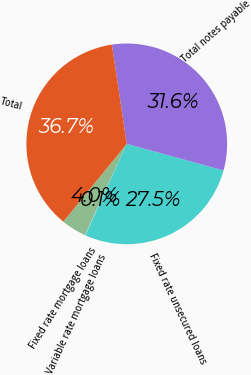<chart> <loc_0><loc_0><loc_500><loc_500><pie_chart><fcel>Fixed rate mortgage loans<fcel>Variable rate mortgage loans<fcel>Fixed rate unsecured loans<fcel>Total notes payable<fcel>Total<nl><fcel>4.05%<fcel>0.09%<fcel>27.49%<fcel>31.63%<fcel>36.75%<nl></chart> 